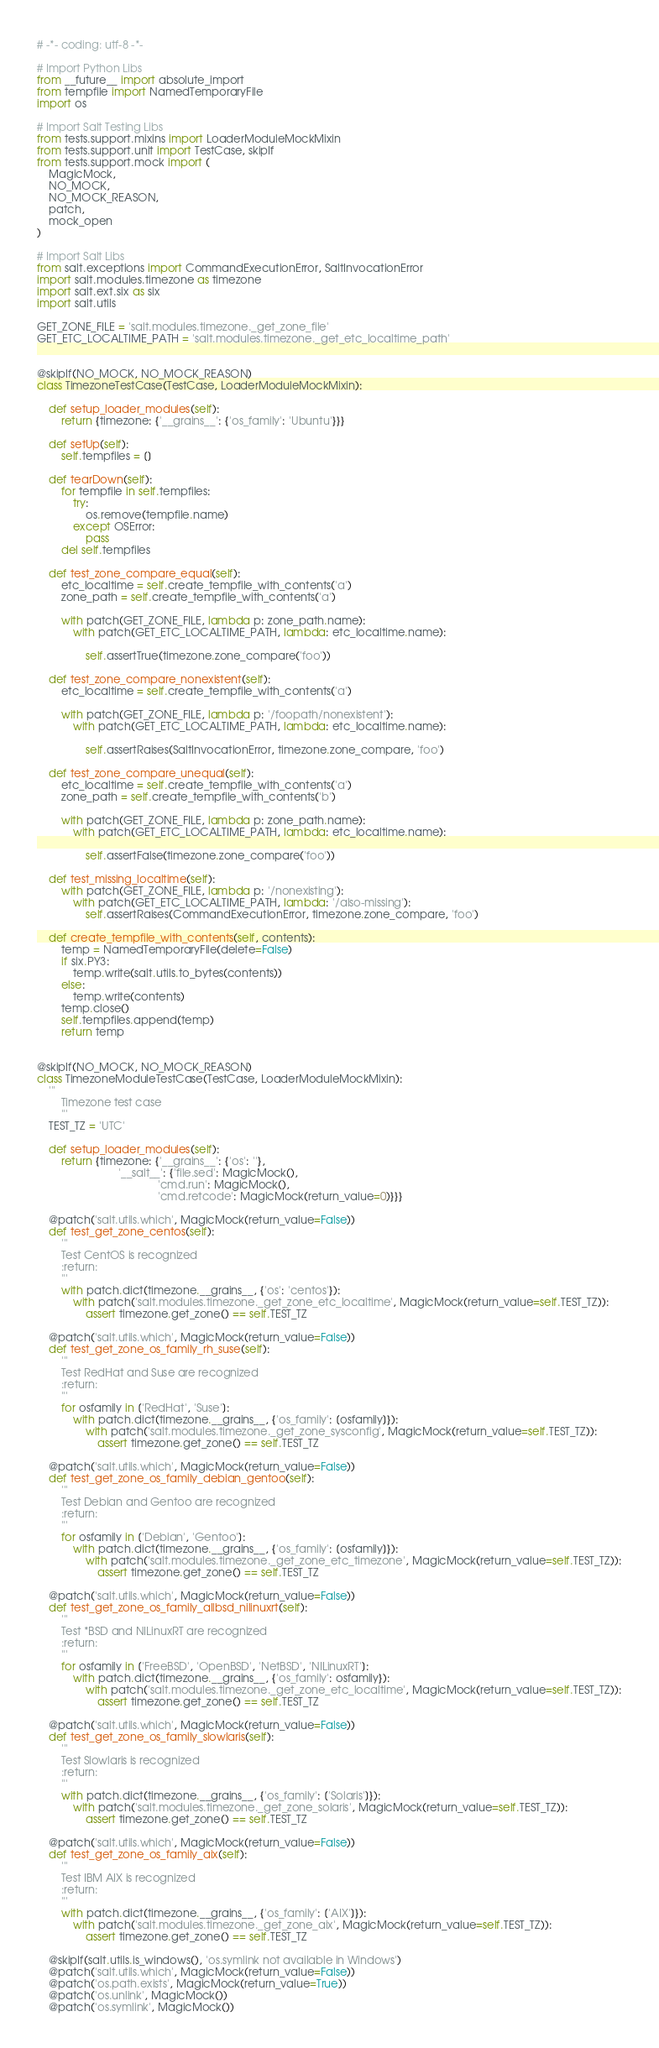Convert code to text. <code><loc_0><loc_0><loc_500><loc_500><_Python_># -*- coding: utf-8 -*-

# Import Python Libs
from __future__ import absolute_import
from tempfile import NamedTemporaryFile
import os

# Import Salt Testing Libs
from tests.support.mixins import LoaderModuleMockMixin
from tests.support.unit import TestCase, skipIf
from tests.support.mock import (
    MagicMock,
    NO_MOCK,
    NO_MOCK_REASON,
    patch,
    mock_open
)

# Import Salt Libs
from salt.exceptions import CommandExecutionError, SaltInvocationError
import salt.modules.timezone as timezone
import salt.ext.six as six
import salt.utils

GET_ZONE_FILE = 'salt.modules.timezone._get_zone_file'
GET_ETC_LOCALTIME_PATH = 'salt.modules.timezone._get_etc_localtime_path'


@skipIf(NO_MOCK, NO_MOCK_REASON)
class TimezoneTestCase(TestCase, LoaderModuleMockMixin):

    def setup_loader_modules(self):
        return {timezone: {'__grains__': {'os_family': 'Ubuntu'}}}

    def setUp(self):
        self.tempfiles = []

    def tearDown(self):
        for tempfile in self.tempfiles:
            try:
                os.remove(tempfile.name)
            except OSError:
                pass
        del self.tempfiles

    def test_zone_compare_equal(self):
        etc_localtime = self.create_tempfile_with_contents('a')
        zone_path = self.create_tempfile_with_contents('a')

        with patch(GET_ZONE_FILE, lambda p: zone_path.name):
            with patch(GET_ETC_LOCALTIME_PATH, lambda: etc_localtime.name):

                self.assertTrue(timezone.zone_compare('foo'))

    def test_zone_compare_nonexistent(self):
        etc_localtime = self.create_tempfile_with_contents('a')

        with patch(GET_ZONE_FILE, lambda p: '/foopath/nonexistent'):
            with patch(GET_ETC_LOCALTIME_PATH, lambda: etc_localtime.name):

                self.assertRaises(SaltInvocationError, timezone.zone_compare, 'foo')

    def test_zone_compare_unequal(self):
        etc_localtime = self.create_tempfile_with_contents('a')
        zone_path = self.create_tempfile_with_contents('b')

        with patch(GET_ZONE_FILE, lambda p: zone_path.name):
            with patch(GET_ETC_LOCALTIME_PATH, lambda: etc_localtime.name):

                self.assertFalse(timezone.zone_compare('foo'))

    def test_missing_localtime(self):
        with patch(GET_ZONE_FILE, lambda p: '/nonexisting'):
            with patch(GET_ETC_LOCALTIME_PATH, lambda: '/also-missing'):
                self.assertRaises(CommandExecutionError, timezone.zone_compare, 'foo')

    def create_tempfile_with_contents(self, contents):
        temp = NamedTemporaryFile(delete=False)
        if six.PY3:
            temp.write(salt.utils.to_bytes(contents))
        else:
            temp.write(contents)
        temp.close()
        self.tempfiles.append(temp)
        return temp


@skipIf(NO_MOCK, NO_MOCK_REASON)
class TimezoneModuleTestCase(TestCase, LoaderModuleMockMixin):
    '''
        Timezone test case
        '''
    TEST_TZ = 'UTC'

    def setup_loader_modules(self):
        return {timezone: {'__grains__': {'os': ''},
                           '__salt__': {'file.sed': MagicMock(),
                                        'cmd.run': MagicMock(),
                                        'cmd.retcode': MagicMock(return_value=0)}}}

    @patch('salt.utils.which', MagicMock(return_value=False))
    def test_get_zone_centos(self):
        '''
        Test CentOS is recognized
        :return:
        '''
        with patch.dict(timezone.__grains__, {'os': 'centos'}):
            with patch('salt.modules.timezone._get_zone_etc_localtime', MagicMock(return_value=self.TEST_TZ)):
                assert timezone.get_zone() == self.TEST_TZ

    @patch('salt.utils.which', MagicMock(return_value=False))
    def test_get_zone_os_family_rh_suse(self):
        '''
        Test RedHat and Suse are recognized
        :return:
        '''
        for osfamily in ['RedHat', 'Suse']:
            with patch.dict(timezone.__grains__, {'os_family': [osfamily]}):
                with patch('salt.modules.timezone._get_zone_sysconfig', MagicMock(return_value=self.TEST_TZ)):
                    assert timezone.get_zone() == self.TEST_TZ

    @patch('salt.utils.which', MagicMock(return_value=False))
    def test_get_zone_os_family_debian_gentoo(self):
        '''
        Test Debian and Gentoo are recognized
        :return:
        '''
        for osfamily in ['Debian', 'Gentoo']:
            with patch.dict(timezone.__grains__, {'os_family': [osfamily]}):
                with patch('salt.modules.timezone._get_zone_etc_timezone', MagicMock(return_value=self.TEST_TZ)):
                    assert timezone.get_zone() == self.TEST_TZ

    @patch('salt.utils.which', MagicMock(return_value=False))
    def test_get_zone_os_family_allbsd_nilinuxrt(self):
        '''
        Test *BSD and NILinuxRT are recognized
        :return:
        '''
        for osfamily in ['FreeBSD', 'OpenBSD', 'NetBSD', 'NILinuxRT']:
            with patch.dict(timezone.__grains__, {'os_family': osfamily}):
                with patch('salt.modules.timezone._get_zone_etc_localtime', MagicMock(return_value=self.TEST_TZ)):
                    assert timezone.get_zone() == self.TEST_TZ

    @patch('salt.utils.which', MagicMock(return_value=False))
    def test_get_zone_os_family_slowlaris(self):
        '''
        Test Slowlaris is recognized
        :return:
        '''
        with patch.dict(timezone.__grains__, {'os_family': ['Solaris']}):
            with patch('salt.modules.timezone._get_zone_solaris', MagicMock(return_value=self.TEST_TZ)):
                assert timezone.get_zone() == self.TEST_TZ

    @patch('salt.utils.which', MagicMock(return_value=False))
    def test_get_zone_os_family_aix(self):
        '''
        Test IBM AIX is recognized
        :return:
        '''
        with patch.dict(timezone.__grains__, {'os_family': ['AIX']}):
            with patch('salt.modules.timezone._get_zone_aix', MagicMock(return_value=self.TEST_TZ)):
                assert timezone.get_zone() == self.TEST_TZ

    @skipIf(salt.utils.is_windows(), 'os.symlink not available in Windows')
    @patch('salt.utils.which', MagicMock(return_value=False))
    @patch('os.path.exists', MagicMock(return_value=True))
    @patch('os.unlink', MagicMock())
    @patch('os.symlink', MagicMock())</code> 